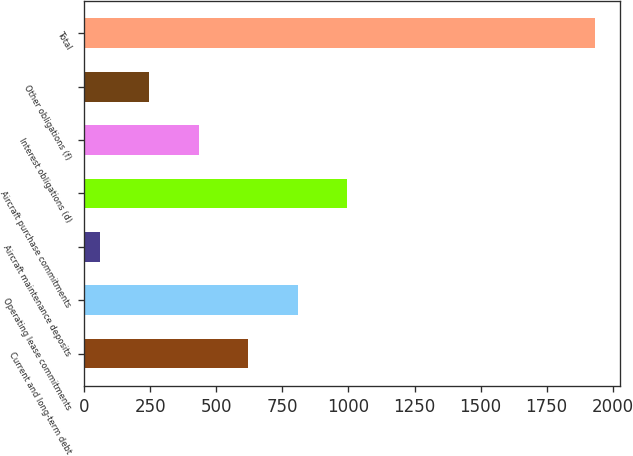<chart> <loc_0><loc_0><loc_500><loc_500><bar_chart><fcel>Current and long-term debt<fcel>Operating lease commitments<fcel>Aircraft maintenance deposits<fcel>Aircraft purchase commitments<fcel>Interest obligations (d)<fcel>Other obligations (f)<fcel>Total<nl><fcel>620.6<fcel>807.8<fcel>59<fcel>995<fcel>433.4<fcel>246.2<fcel>1931<nl></chart> 